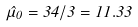<formula> <loc_0><loc_0><loc_500><loc_500>\hat { \mu } _ { 0 } = 3 4 / 3 = 1 1 . 3 3</formula> 